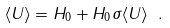<formula> <loc_0><loc_0><loc_500><loc_500>\langle U \rangle = H _ { 0 } + H _ { 0 } \sigma \langle U \rangle \ .</formula> 